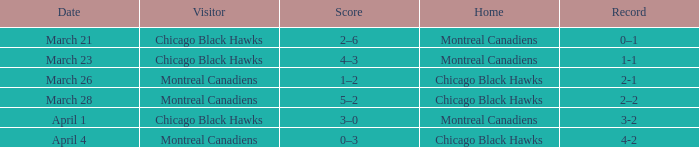What is the score for the team with a record of 2-1? 1–2. 